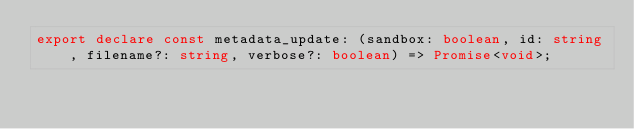<code> <loc_0><loc_0><loc_500><loc_500><_TypeScript_>export declare const metadata_update: (sandbox: boolean, id: string, filename?: string, verbose?: boolean) => Promise<void>;
</code> 